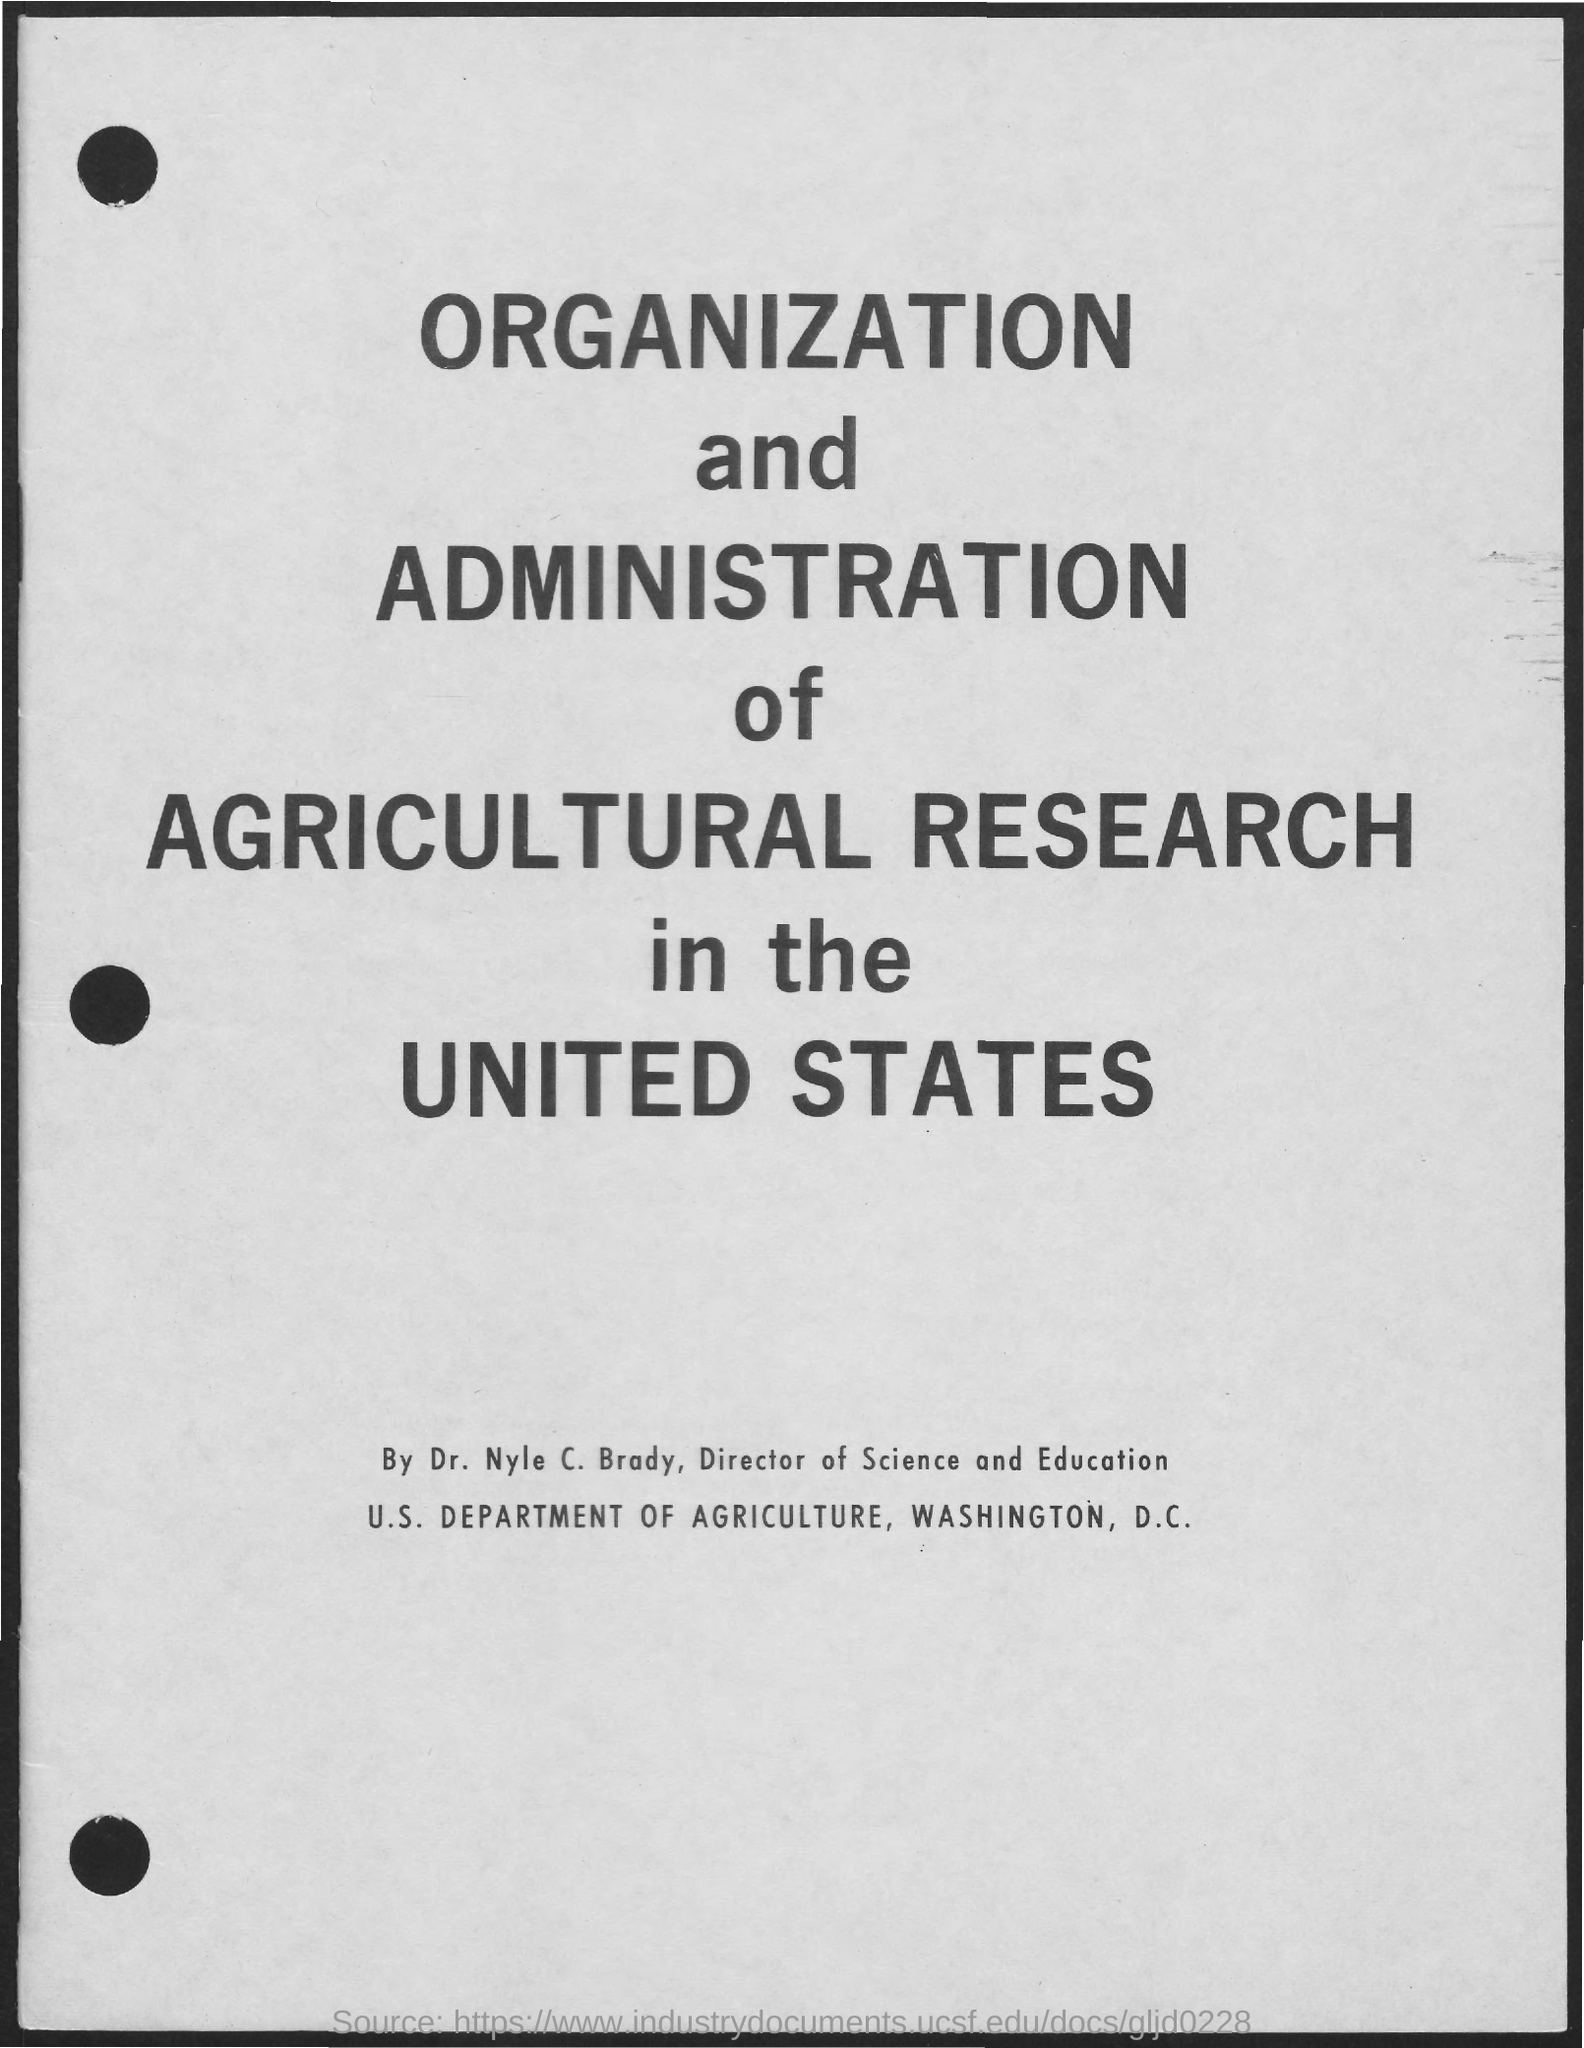Who is the director of Science and Education?
Ensure brevity in your answer.  Dr. Nyle C. Brady. What is the location for U.S. Department of Agriculture ?
Offer a terse response. Washington, D.C. 